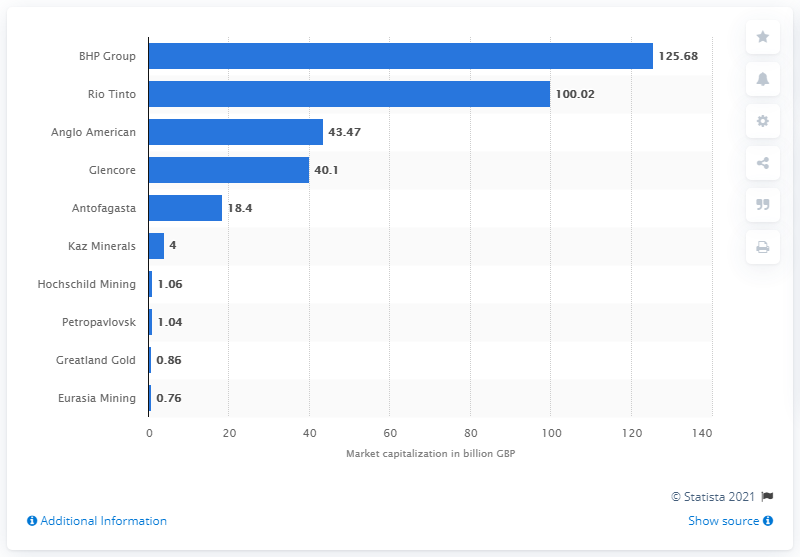Mention a couple of crucial points in this snapshot. As of April 2021, BHP Group was the mining company with the highest market capitalization in the UK. As of April 2021, BHP Group's market capitalization was 125.68. 